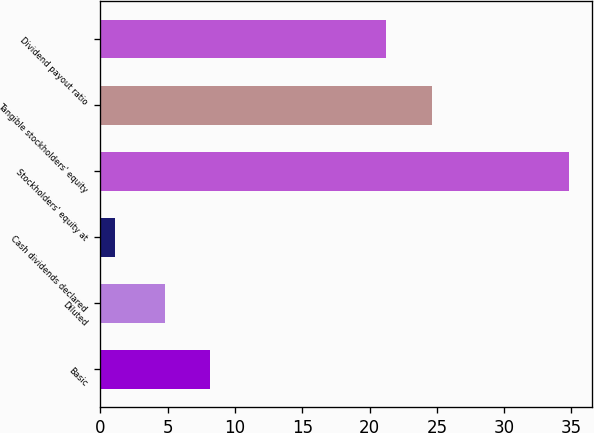Convert chart to OTSL. <chart><loc_0><loc_0><loc_500><loc_500><bar_chart><fcel>Basic<fcel>Diluted<fcel>Cash dividends declared<fcel>Stockholders' equity at<fcel>Tangible stockholders' equity<fcel>Dividend payout ratio<nl><fcel>8.16<fcel>4.78<fcel>1.05<fcel>34.82<fcel>24.62<fcel>21.24<nl></chart> 